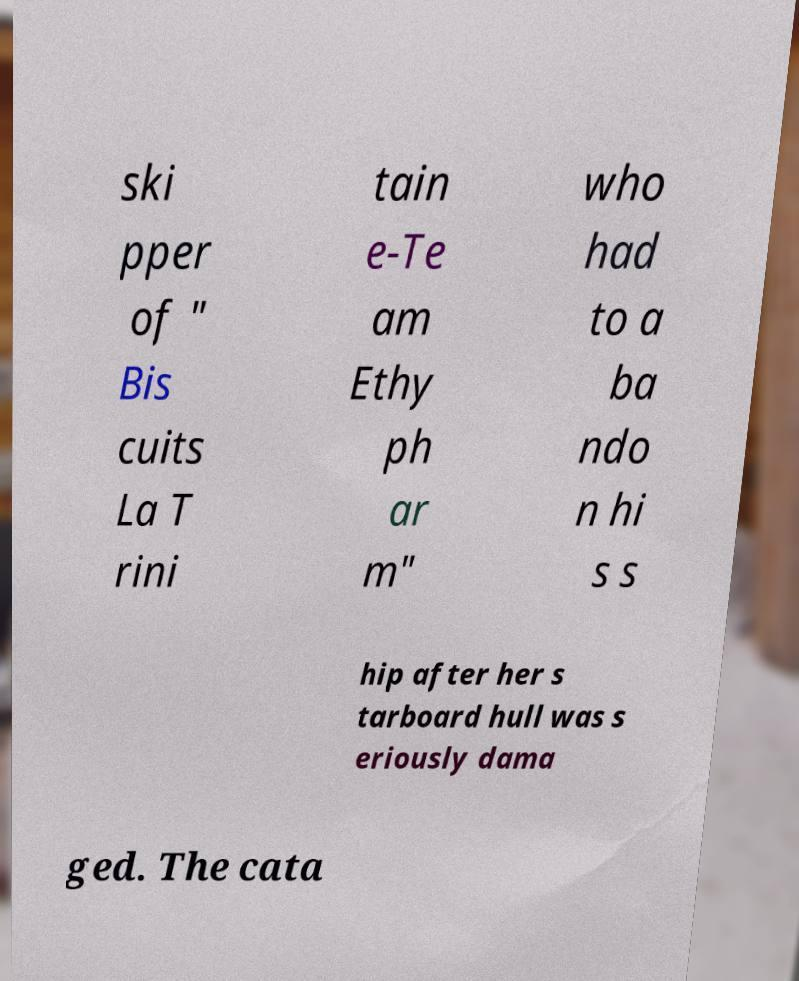Could you assist in decoding the text presented in this image and type it out clearly? ski pper of " Bis cuits La T rini tain e-Te am Ethy ph ar m" who had to a ba ndo n hi s s hip after her s tarboard hull was s eriously dama ged. The cata 